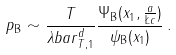Convert formula to latex. <formula><loc_0><loc_0><loc_500><loc_500>p _ { \text {B} } \sim \frac { T } { \lambda b a r _ { T , 1 } ^ { d } } \frac { \Psi _ { \text {B} } ( x _ { 1 } , \frac { a } { \L c } ) } { \psi _ { \text {B} } ( x _ { 1 } ) } \, .</formula> 